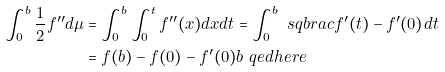<formula> <loc_0><loc_0><loc_500><loc_500>\int _ { 0 } ^ { b } \frac { 1 } { 2 } f ^ { \prime \prime } d \mu & = \int _ { 0 } ^ { b } \int _ { 0 } ^ { t } f ^ { \prime \prime } ( x ) d x d t = \int _ { 0 } ^ { b } \ s q b r a c { f ^ { \prime } ( t ) - f ^ { \prime } ( 0 ) } d t \\ & = f ( b ) - f ( 0 ) - f ^ { \prime } ( 0 ) b \ q e d h e r e</formula> 